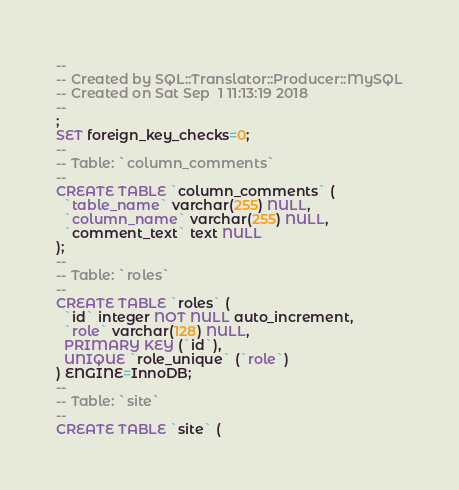Convert code to text. <code><loc_0><loc_0><loc_500><loc_500><_SQL_>-- 
-- Created by SQL::Translator::Producer::MySQL
-- Created on Sat Sep  1 11:13:19 2018
-- 
;
SET foreign_key_checks=0;
--
-- Table: `column_comments`
--
CREATE TABLE `column_comments` (
  `table_name` varchar(255) NULL,
  `column_name` varchar(255) NULL,
  `comment_text` text NULL
);
--
-- Table: `roles`
--
CREATE TABLE `roles` (
  `id` integer NOT NULL auto_increment,
  `role` varchar(128) NULL,
  PRIMARY KEY (`id`),
  UNIQUE `role_unique` (`role`)
) ENGINE=InnoDB;
--
-- Table: `site`
--
CREATE TABLE `site` (</code> 